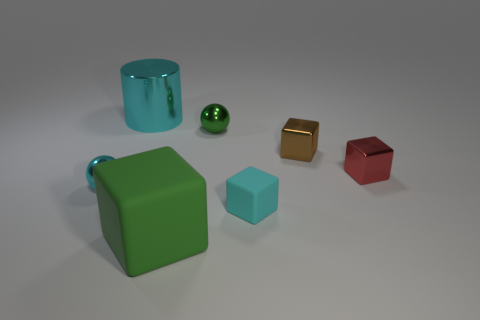Add 2 yellow shiny balls. How many objects exist? 9 Subtract all brown blocks. Subtract all purple balls. How many blocks are left? 3 Subtract all cylinders. How many objects are left? 6 Subtract 1 cyan cubes. How many objects are left? 6 Subtract all shiny objects. Subtract all large green objects. How many objects are left? 1 Add 4 tiny brown cubes. How many tiny brown cubes are left? 5 Add 4 green metallic balls. How many green metallic balls exist? 5 